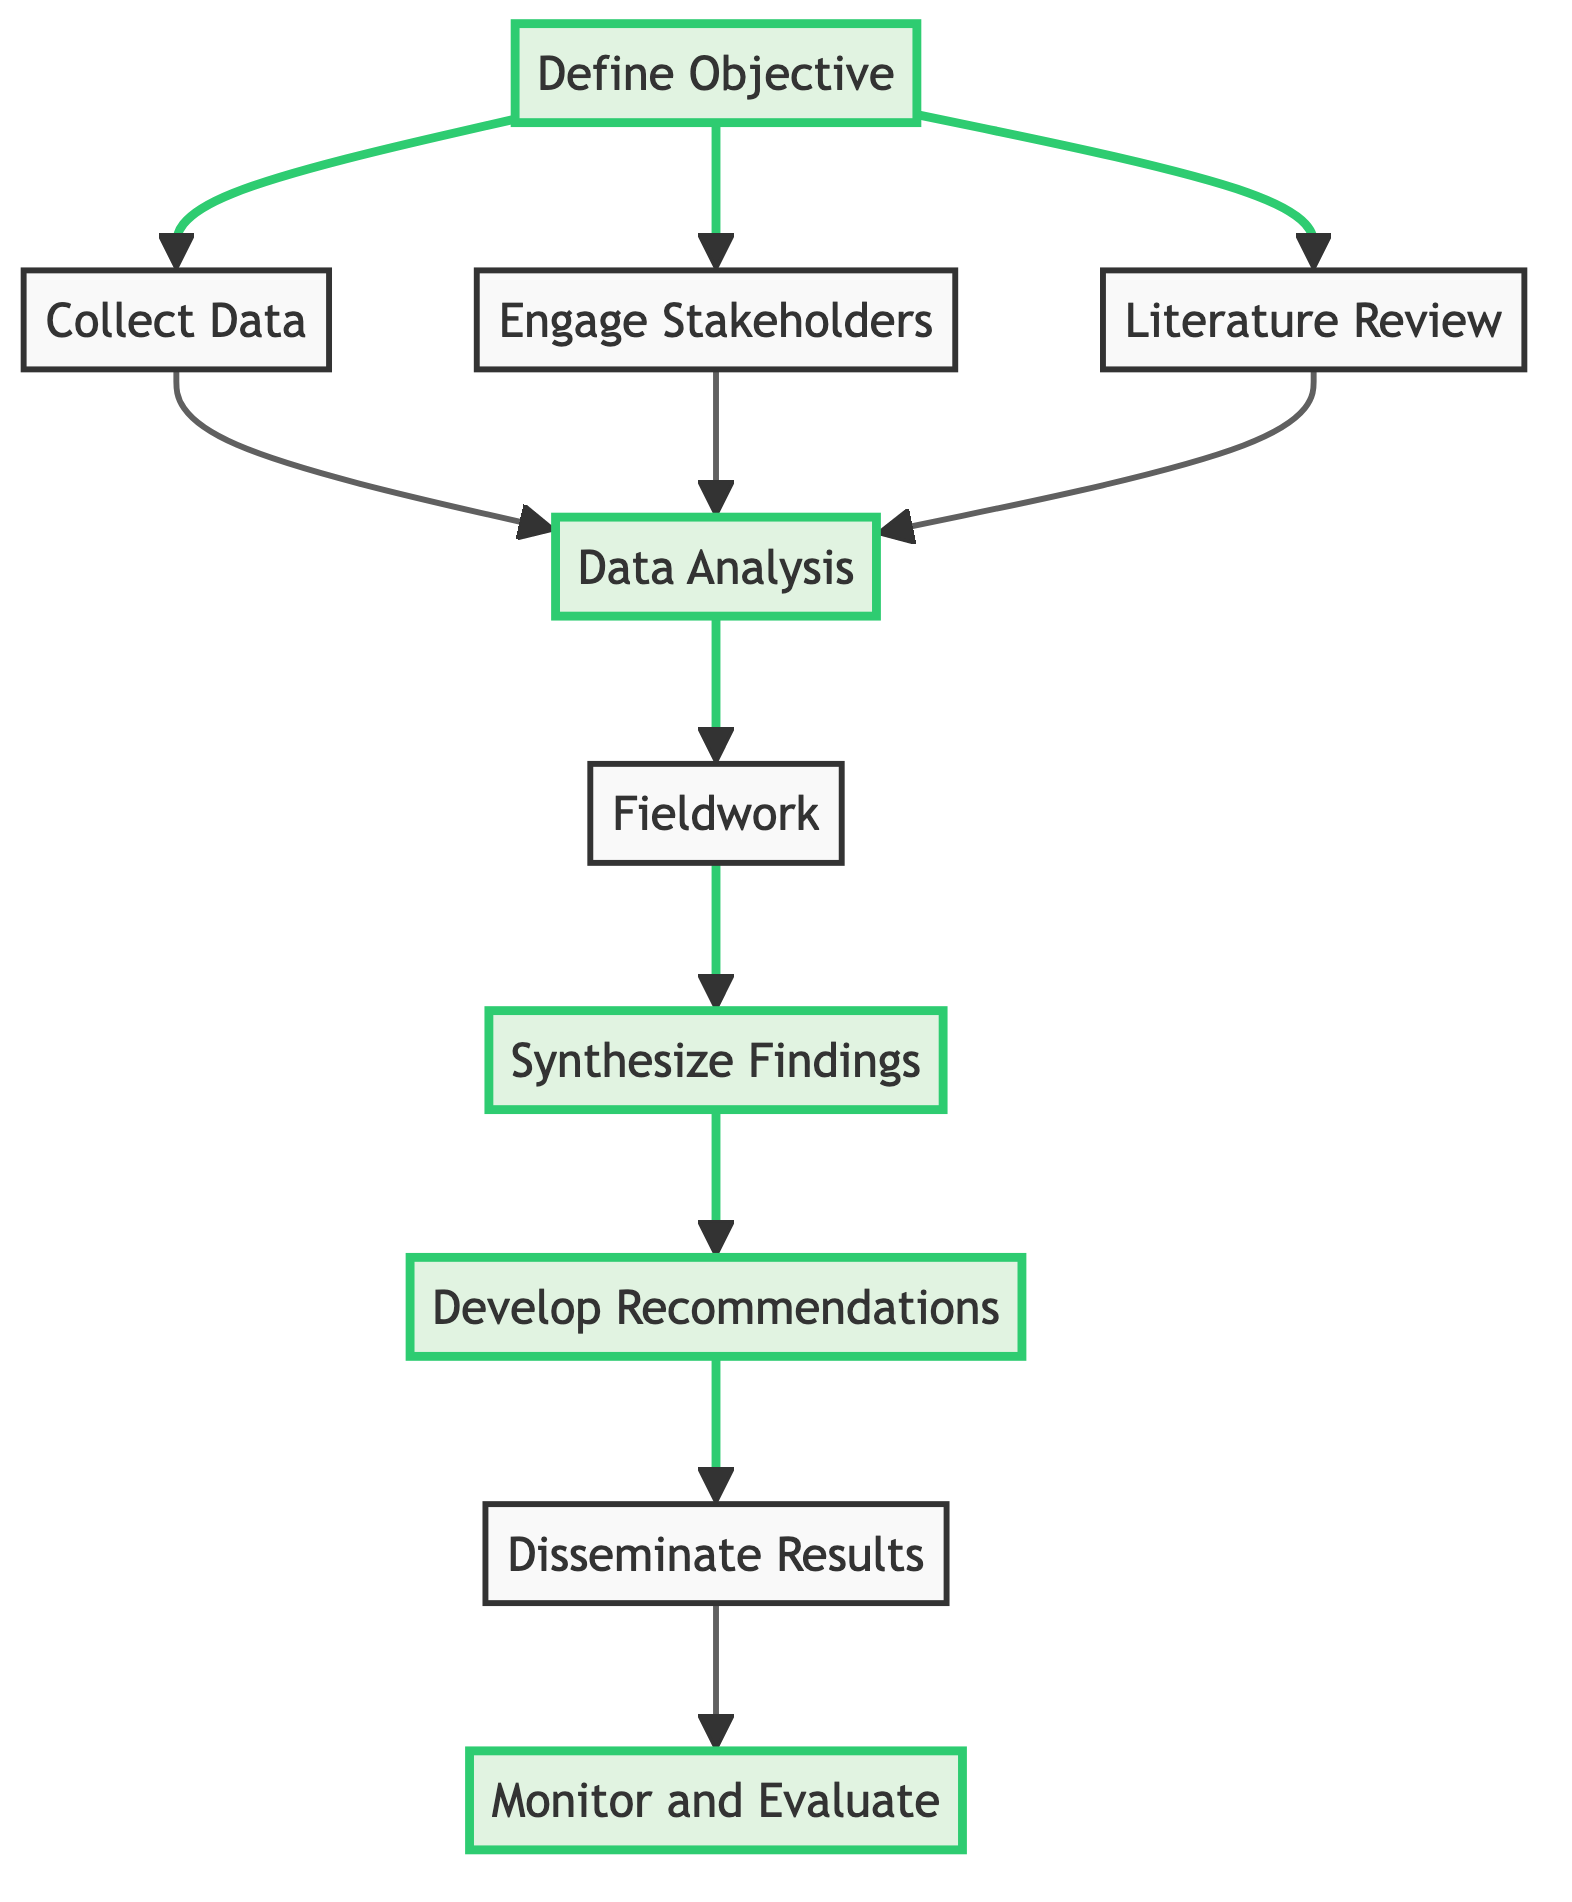What is the first step in the flowchart? The first step in the flowchart is to "Define Objective," which is indicated as the starting node of the diagram.
Answer: Define Objective How many total nodes are present in the diagram? By counting each distinct step in the flowchart, there are ten nodes illustrated in total.
Answer: 10 Which step follows "Data Analysis"? The step that follows "Data Analysis" is "Fieldwork," as indicated by the arrow connecting the two nodes.
Answer: Fieldwork What is the last step indicated in the flowchart? The last step in the flowchart is "Monitor and Evaluate," which is the final node that follows all previous steps.
Answer: Monitor and Evaluate How many steps connect to "Data Analysis"? Three steps connect to "Data Analysis": "Collect Data," "Engage Stakeholders," and "Literature Review."
Answer: 3 What type of data is gathered in "Collect Data"? The types of data gathered in "Collect Data" include poverty rates, employment statistics, educational attainment, and local economic activities.
Answer: Socioeconomic data Which nodes are highlighted in the diagram? The highlighted nodes in the diagram are "Define Objective," "Data Analysis," "Synthesize Findings," "Develop Recommendations," and "Monitor and Evaluate."
Answer: Define Objective, Data Analysis, Synthesize Findings, Develop Recommendations, Monitor and Evaluate What is the purpose of "Synthesize Findings"? The purpose of "Synthesize Findings" is to combine quantitative and qualitative data to form a comprehensive view of the socioeconomic drivers of poaching.
Answer: Combine data What is meant by "Engage Stakeholders" in the context of this flowchart? "Engage Stakeholders" refers to the process of consulting with local communities, NGOs, conservation groups, and government agencies for qualitative insights in the study.
Answer: Gain qualitative insights 